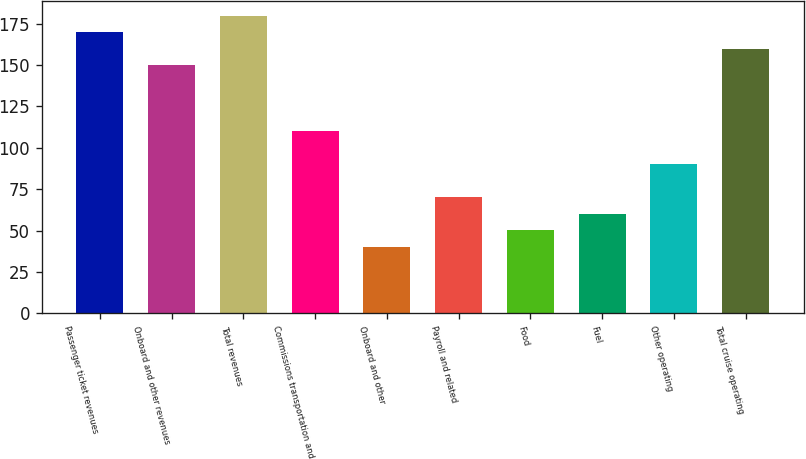<chart> <loc_0><loc_0><loc_500><loc_500><bar_chart><fcel>Passenger ticket revenues<fcel>Onboard and other revenues<fcel>Total revenues<fcel>Commissions transportation and<fcel>Onboard and other<fcel>Payroll and related<fcel>Food<fcel>Fuel<fcel>Other operating<fcel>Total cruise operating<nl><fcel>169.93<fcel>149.95<fcel>179.92<fcel>109.99<fcel>40.06<fcel>70.03<fcel>50.05<fcel>60.04<fcel>90.01<fcel>159.94<nl></chart> 